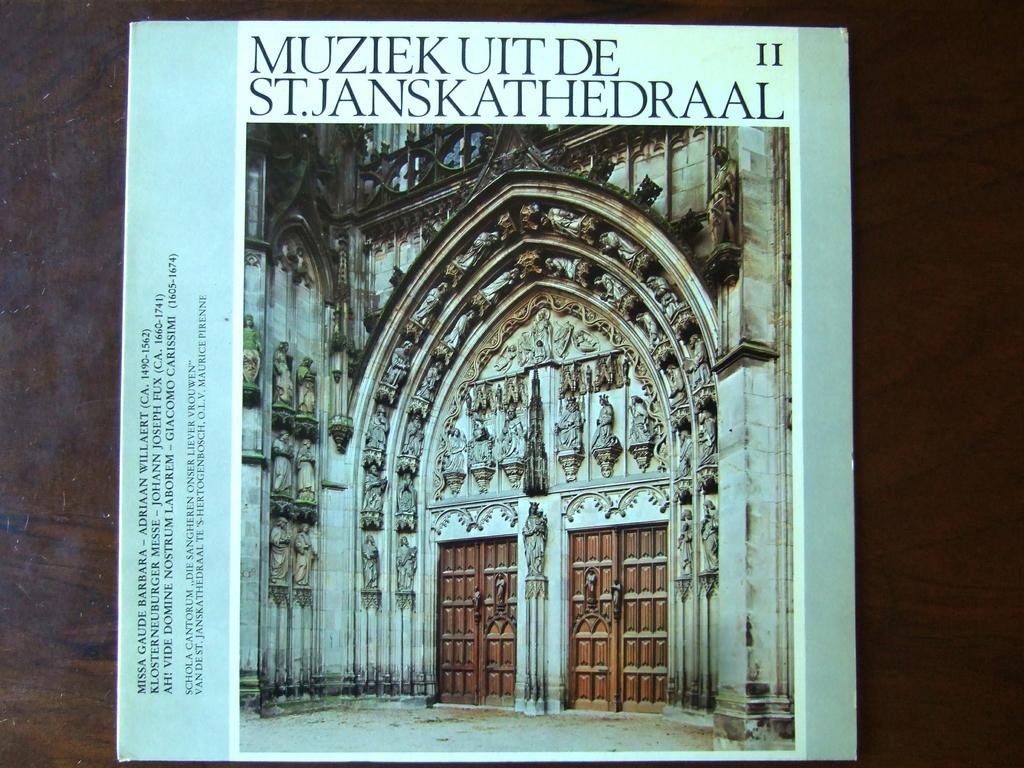In one or two sentences, can you explain what this image depicts? In this picture we can observe a cover page of a book. We can observe a wall. There are carvings on the wall. We can observe two brown color doors. There are black color words on this cover page. The background is dark. 